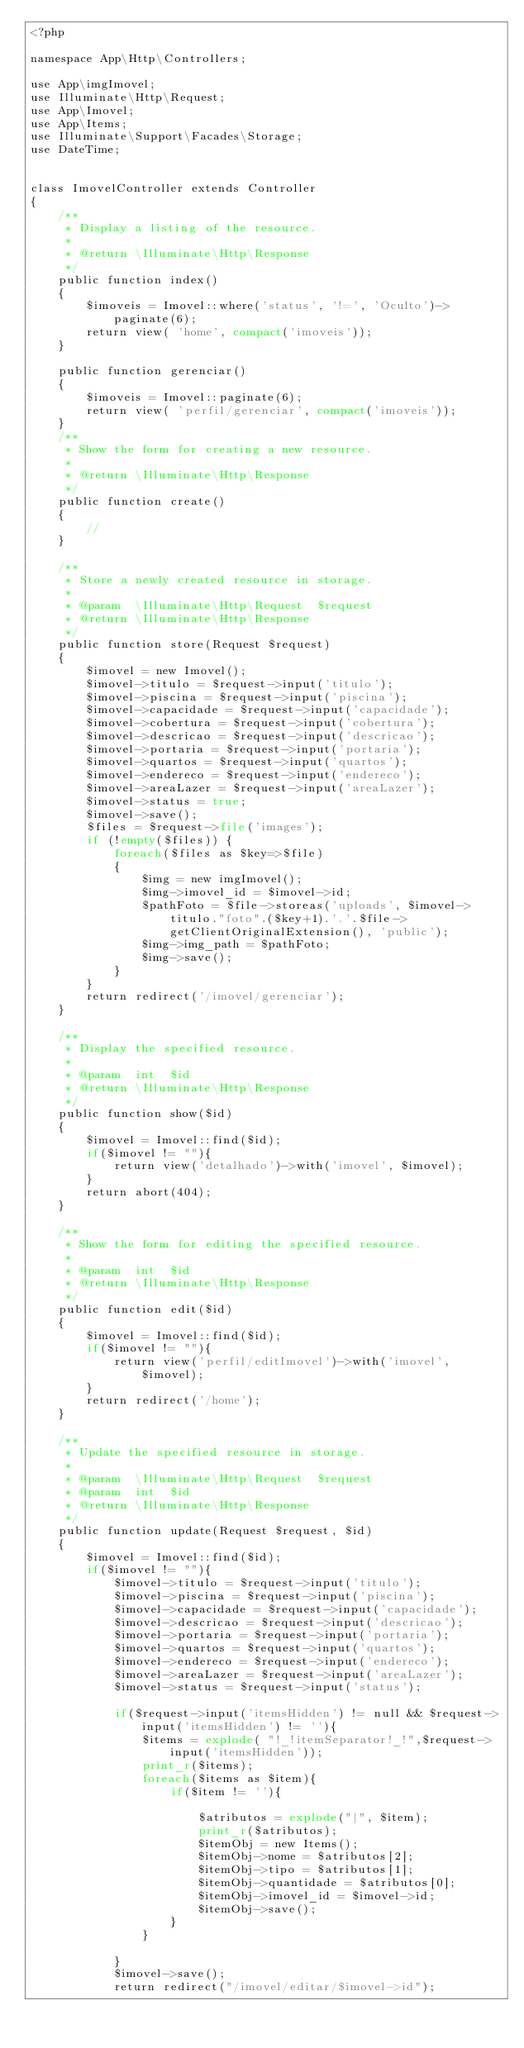Convert code to text. <code><loc_0><loc_0><loc_500><loc_500><_PHP_><?php

namespace App\Http\Controllers;

use App\imgImovel;
use Illuminate\Http\Request;
use App\Imovel;
use App\Items;
use Illuminate\Support\Facades\Storage;
use DateTime;


class ImovelController extends Controller
{
    /**
     * Display a listing of the resource.
     *
     * @return \Illuminate\Http\Response
     */
    public function index()
    {
        $imoveis = Imovel::where('status', '!=', 'Oculto')->paginate(6);
        return view( 'home', compact('imoveis'));
    }

    public function gerenciar()
    {
        $imoveis = Imovel::paginate(6);
        return view( 'perfil/gerenciar', compact('imoveis'));
    }
    /**
     * Show the form for creating a new resource.
     *
     * @return \Illuminate\Http\Response
     */
    public function create()
    {
        //
    }

    /**
     * Store a newly created resource in storage.
     *
     * @param  \Illuminate\Http\Request  $request
     * @return \Illuminate\Http\Response
     */
    public function store(Request $request)
    {         
        $imovel = new Imovel();
        $imovel->titulo = $request->input('titulo');
        $imovel->piscina = $request->input('piscina');
        $imovel->capacidade = $request->input('capacidade');
        $imovel->cobertura = $request->input('cobertura');
        $imovel->descricao = $request->input('descricao');
        $imovel->portaria = $request->input('portaria');
        $imovel->quartos = $request->input('quartos');
        $imovel->endereco = $request->input('endereco');
        $imovel->areaLazer = $request->input('areaLazer');
        $imovel->status = true;
        $imovel->save();
        $files = $request->file('images');
        if (!empty($files)) {
            foreach($files as $key=>$file)
            {
                $img = new imgImovel();
                $img->imovel_id = $imovel->id;                          
                $pathFoto = $file->storeas('uploads', $imovel->titulo."foto".($key+1).'.'.$file->getClientOriginalExtension(), 'public');
                $img->img_path = $pathFoto;
                $img->save();
            }
        }
        return redirect('/imovel/gerenciar');
    }

    /**
     * Display the specified resource.
     *
     * @param  int  $id
     * @return \Illuminate\Http\Response
     */
    public function show($id)
    {
        $imovel = Imovel::find($id);
        if($imovel != ""){
            return view('detalhado')->with('imovel', $imovel);
        }
        return abort(404);
    }

    /**
     * Show the form for editing the specified resource.
     *
     * @param  int  $id
     * @return \Illuminate\Http\Response
     */
    public function edit($id)
    {
        $imovel = Imovel::find($id);
        if($imovel != ""){
            return view('perfil/editImovel')->with('imovel', $imovel);
        }
        return redirect('/home');
    }

    /**
     * Update the specified resource in storage.
     *
     * @param  \Illuminate\Http\Request  $request
     * @param  int  $id
     * @return \Illuminate\Http\Response
     */
    public function update(Request $request, $id)
    {
        $imovel = Imovel::find($id);
        if($imovel != ""){
            $imovel->titulo = $request->input('titulo');
            $imovel->piscina = $request->input('piscina');
            $imovel->capacidade = $request->input('capacidade');
            $imovel->descricao = $request->input('descricao');
            $imovel->portaria = $request->input('portaria');
            $imovel->quartos = $request->input('quartos');
            $imovel->endereco = $request->input('endereco');
            $imovel->areaLazer = $request->input('areaLazer');
            $imovel->status = $request->input('status');
            
            if($request->input('itemsHidden') != null && $request->input('itemsHidden') != ''){
                $items = explode( "!_!itemSeparator!_!",$request->input('itemsHidden'));
                print_r($items);
                foreach($items as $item){
                    if($item != ''){

                        $atributos = explode("|", $item);
                        print_r($atributos);
                        $itemObj = new Items();
                        $itemObj->nome = $atributos[2];
                        $itemObj->tipo = $atributos[1];
                        $itemObj->quantidade = $atributos[0];
                        $itemObj->imovel_id = $imovel->id;
                        $itemObj->save();       
                    }
                }
               
            }
            $imovel->save();
            return redirect("/imovel/editar/$imovel->id");</code> 